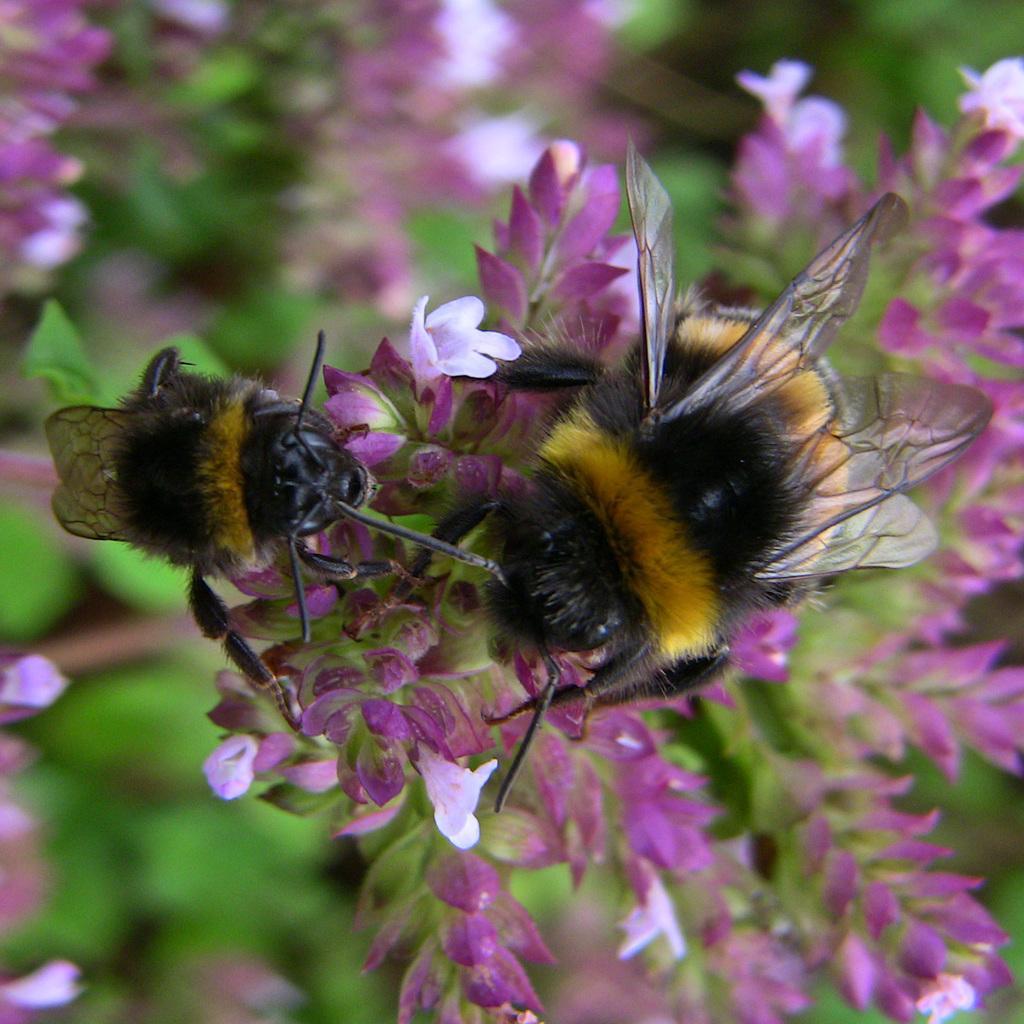In one or two sentences, can you explain what this image depicts? In the center of the image we can see bees on the flowers. In the background there are leaves and flowers. 